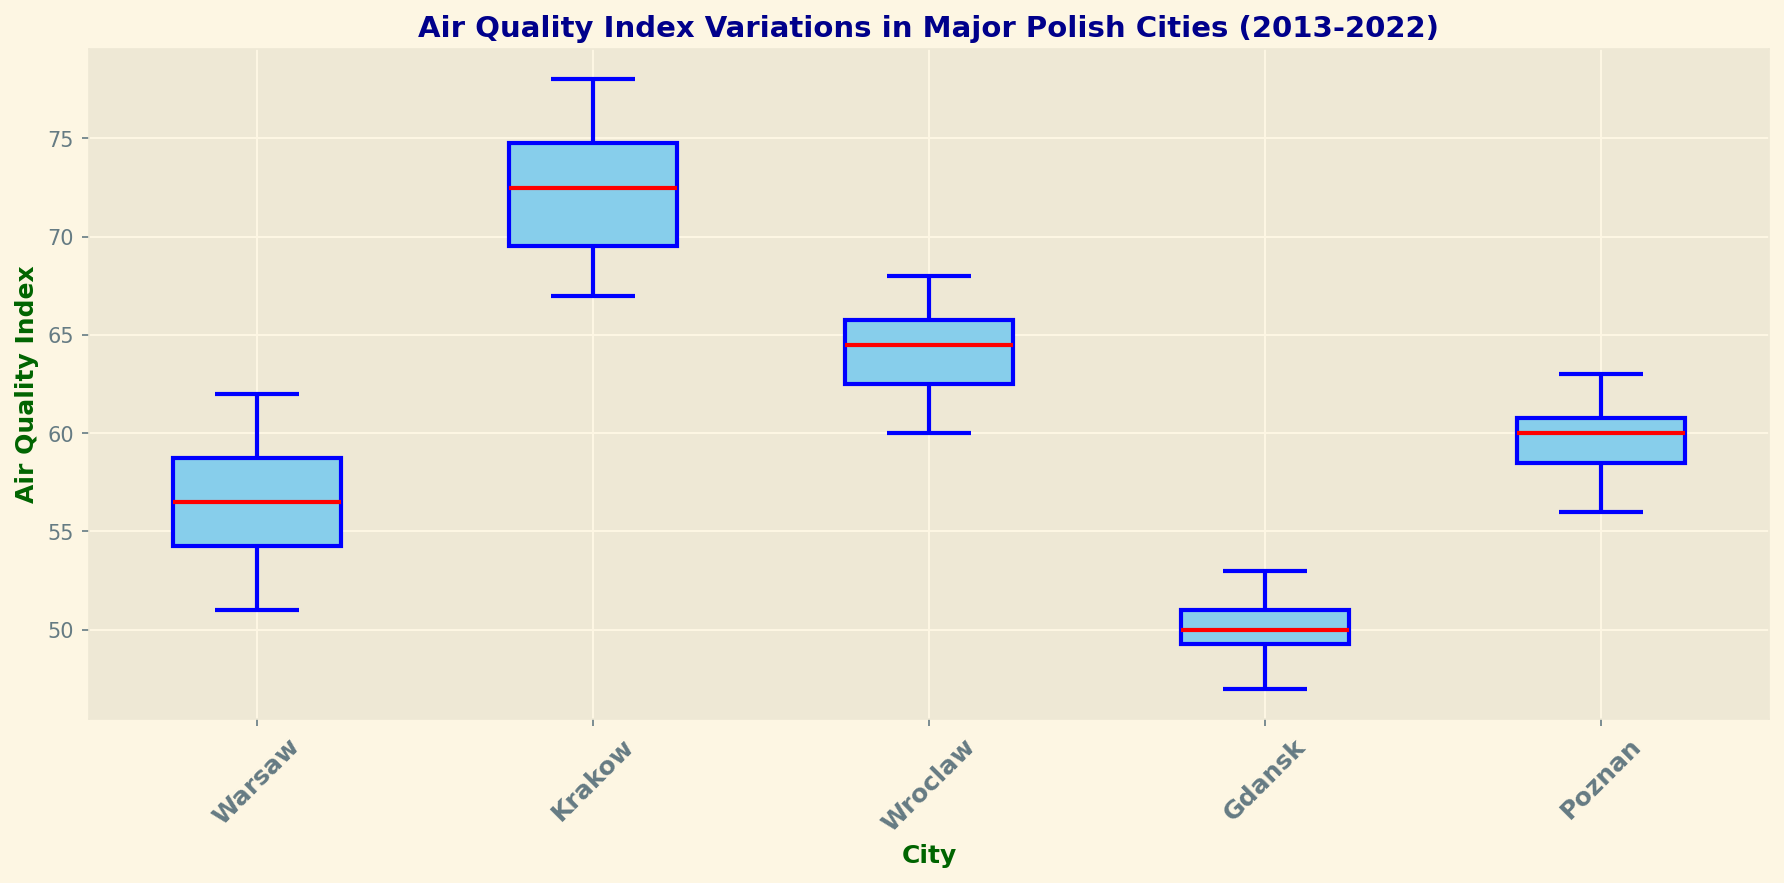Which city has the highest median Air Quality Index (AQI)? To find the city with the highest median AQI, look for the city whose median line (red line) in the box plot is at the highest position.
Answer: Krakow Which city has the lowest median Air Quality Index (AQI)? To find the city with the lowest median AQI, look for the city whose median line (red line) in the box plot is at the lowest position.
Answer: Gdansk What is the range of the Air Quality Index (AQI) for Wroclaw? The range is calculated by subtracting the lowest whisker value from the highest whisker value. For Wroclaw, identify the top of the highest whisker and the bottom of the lowest whisker.
Answer: 8 (68 - 60) Compare the variability of Air Quality Index (AQI) in Warsaw and Poznan. Which city shows more variability? Variability can be assessed by the length of the box and whiskers. A longer box and whiskers indicate higher variability. Compare the lengths of the boxes and whiskers for Warsaw and Poznan.
Answer: Warsaw Which city has the narrowest interquartile range (IQR) for Air Quality Index (AQI)? The interquartile range (IQR) is represented by the height of the box. The city with the shortest box has the narrowest IQR.
Answer: Gdansk By looking at the whiskers and outliers, which city looks like it had more extreme AQI values? Check for cities with longer whiskers or more prominent outliers indicated by dots outside the whiskers. Longer whiskers or more dots suggest extreme values.
Answer: Krakow How does the median AQI of Wroclaw compare to that of Gdansk? Compare the position of the red median line in Wroclaw's box plot to Gdansk's box plot.
Answer: Higher in Wroclaw What is the interquartile range (IQR) of the Air Quality Index (AQI) for Krakow? Identify the lower and upper edges of the box for Krakow and subtract the lower quartile (bottom edge of the box) from the upper quartile (top edge of the box).
Answer: 4 (74 - 70) Which city has the highest maximum AQI value observed? Look for the highest point reached by the top whisker in any of the box plots to determine the city with the highest maximum AQI value.
Answer: Krakow Is Gdansk's median AQI higher or lower than Warsaw's 25th percentile AQI? Identify Gdansk's median (red line in Gdansk's box) and compare it to the bottom of Warsaw's box (25th percentile) to see which is higher.
Answer: Higher 